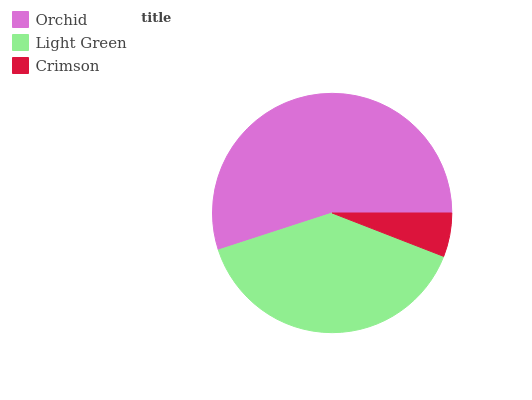Is Crimson the minimum?
Answer yes or no. Yes. Is Orchid the maximum?
Answer yes or no. Yes. Is Light Green the minimum?
Answer yes or no. No. Is Light Green the maximum?
Answer yes or no. No. Is Orchid greater than Light Green?
Answer yes or no. Yes. Is Light Green less than Orchid?
Answer yes or no. Yes. Is Light Green greater than Orchid?
Answer yes or no. No. Is Orchid less than Light Green?
Answer yes or no. No. Is Light Green the high median?
Answer yes or no. Yes. Is Light Green the low median?
Answer yes or no. Yes. Is Orchid the high median?
Answer yes or no. No. Is Orchid the low median?
Answer yes or no. No. 